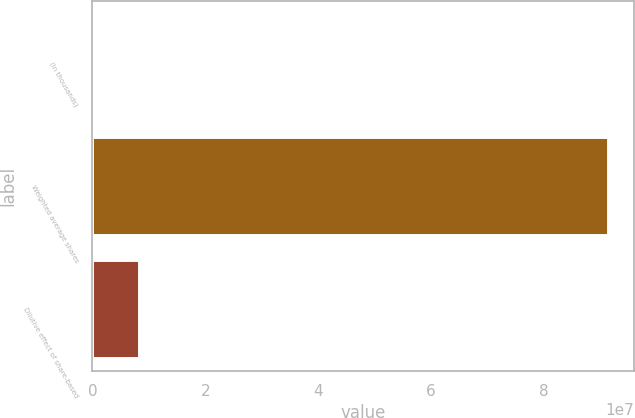<chart> <loc_0><loc_0><loc_500><loc_500><bar_chart><fcel>(In thousands)<fcel>Weighted average shares<fcel>Dilutive effect of share-based<nl><fcel>2016<fcel>9.14272e+07<fcel>8.31718e+06<nl></chart> 